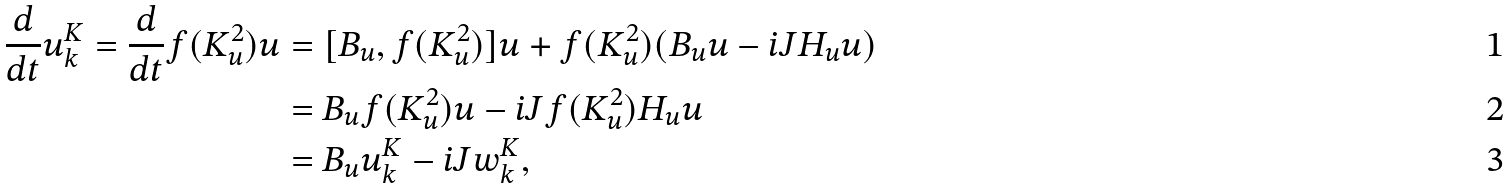Convert formula to latex. <formula><loc_0><loc_0><loc_500><loc_500>\frac { d } { d t } u _ { k } ^ { K } = \frac { d } { d t } f ( K _ { u } ^ { 2 } ) u & = [ B _ { u } , f ( K _ { u } ^ { 2 } ) ] u + f ( K _ { u } ^ { 2 } ) ( B _ { u } u - i J H _ { u } u ) \\ & = B _ { u } f ( K _ { u } ^ { 2 } ) u - i J f ( K _ { u } ^ { 2 } ) H _ { u } u \\ & = B _ { u } u _ { k } ^ { K } - i J w _ { k } ^ { K } ,</formula> 